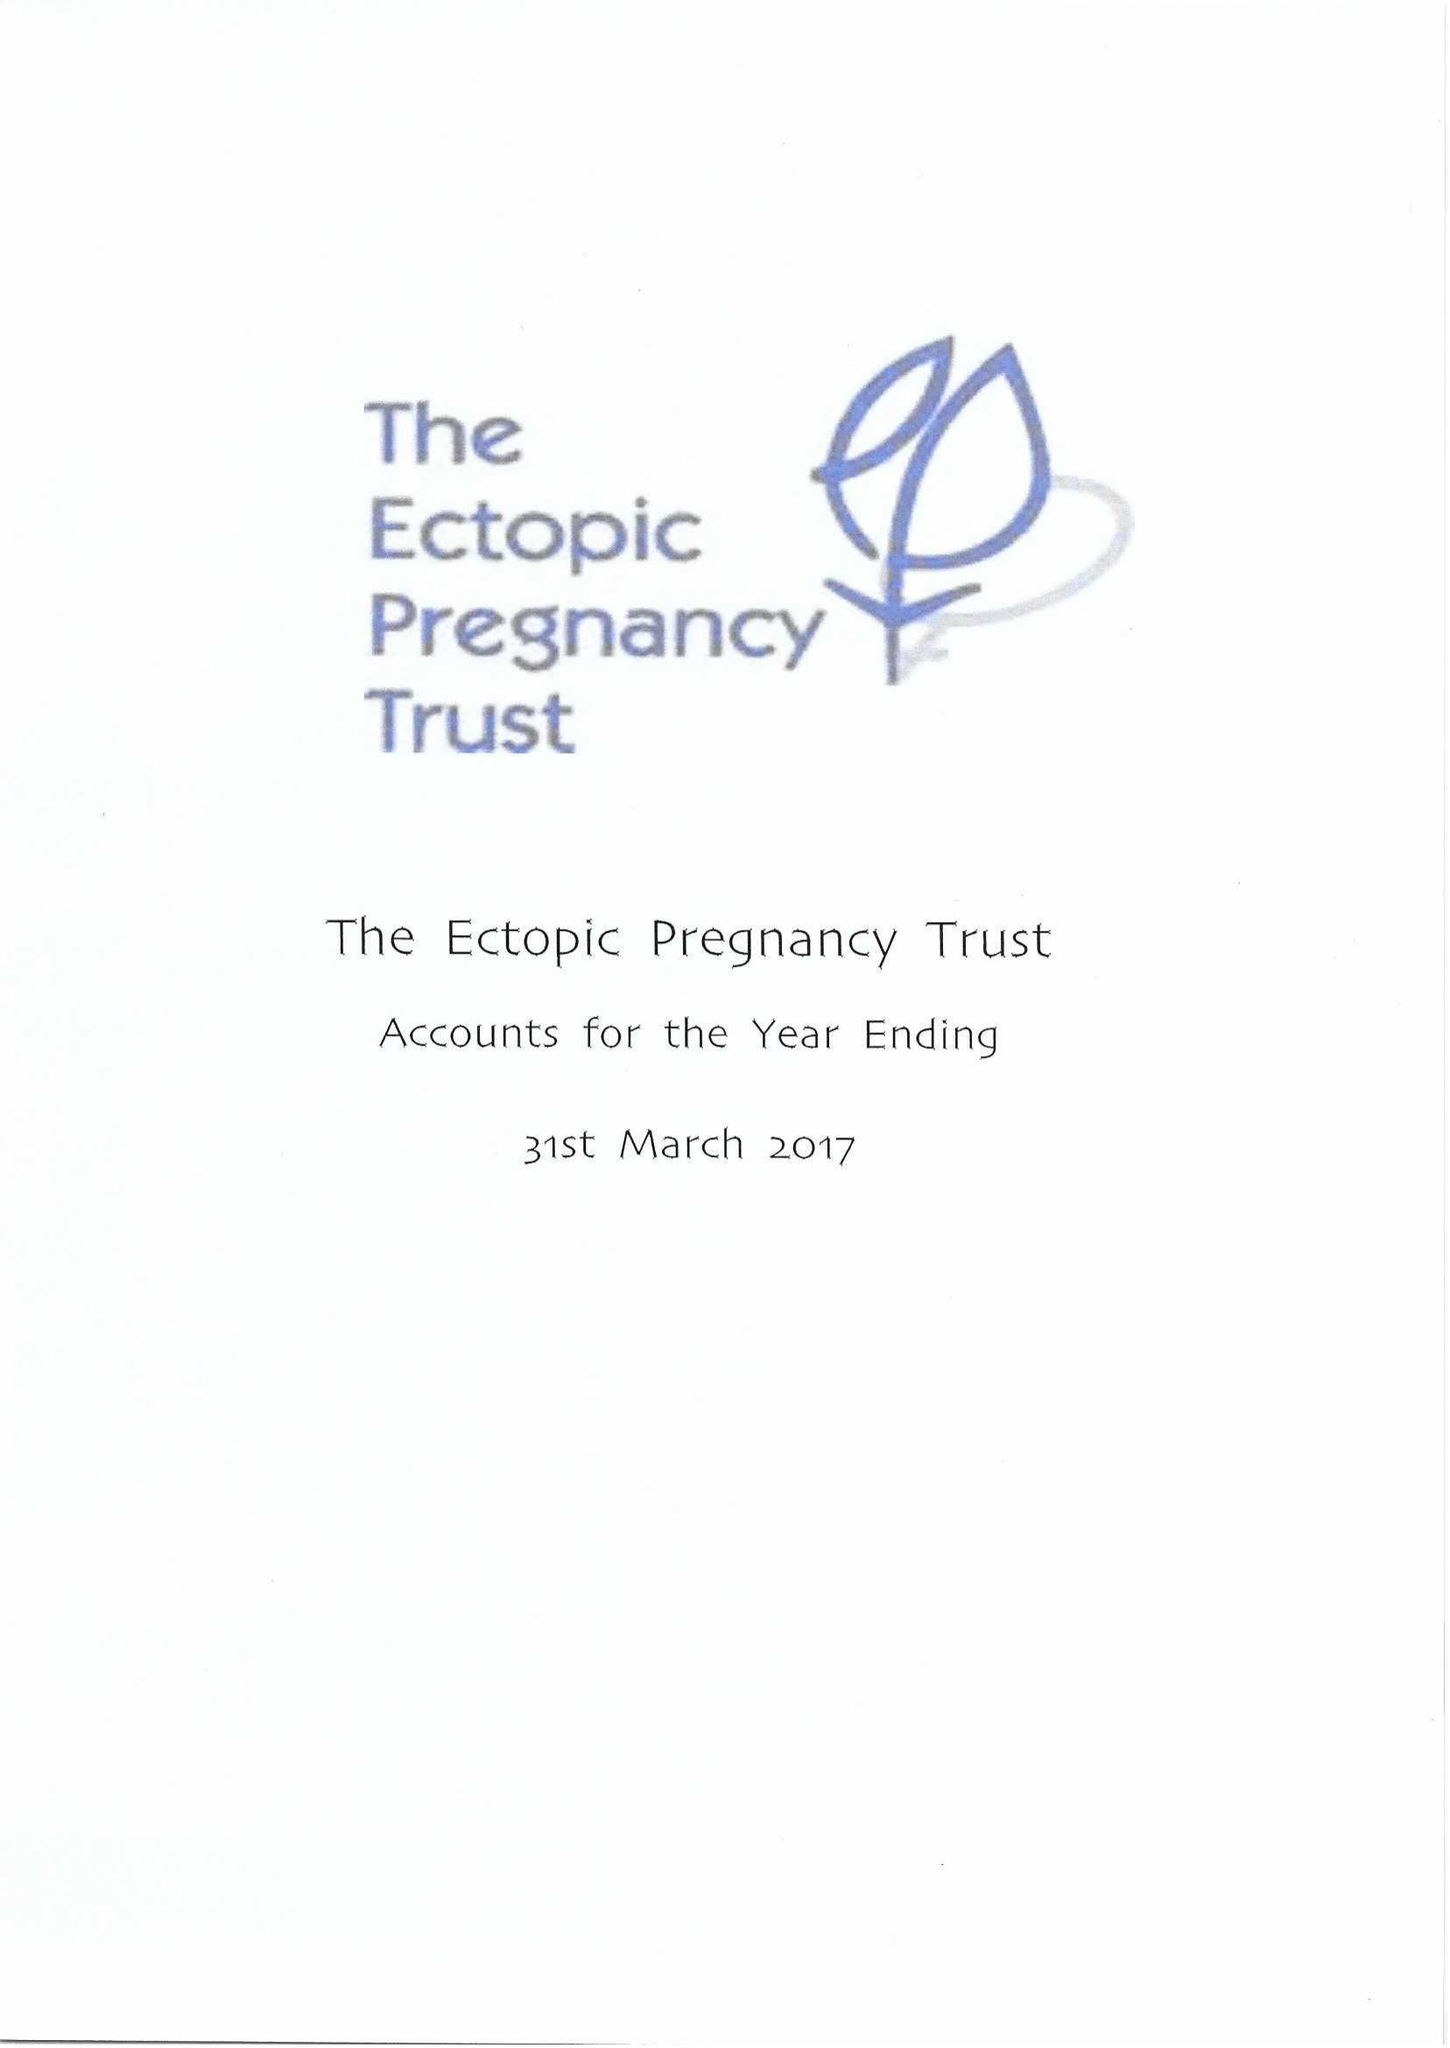What is the value for the income_annually_in_british_pounds?
Answer the question using a single word or phrase. 118898.00 